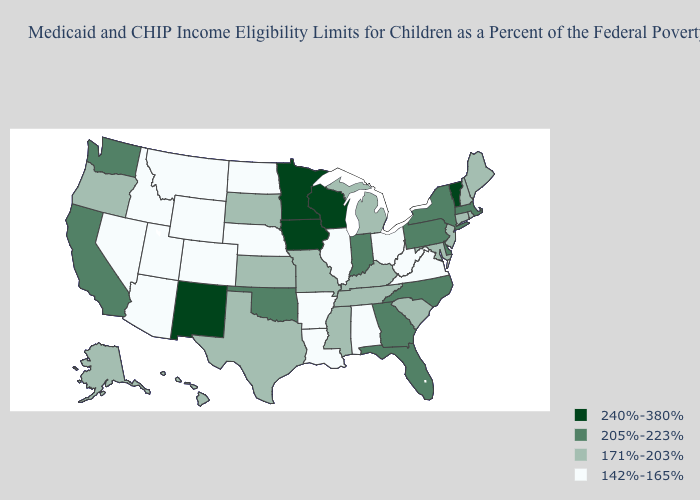Does the map have missing data?
Give a very brief answer. No. What is the highest value in states that border Nebraska?
Concise answer only. 240%-380%. What is the value of Texas?
Be succinct. 171%-203%. Name the states that have a value in the range 205%-223%?
Write a very short answer. California, Delaware, Florida, Georgia, Indiana, Massachusetts, New York, North Carolina, Oklahoma, Pennsylvania, Washington. What is the value of Maine?
Quick response, please. 171%-203%. Among the states that border Idaho , does Oregon have the lowest value?
Short answer required. No. Among the states that border Vermont , does New York have the lowest value?
Quick response, please. No. What is the highest value in states that border New Jersey?
Write a very short answer. 205%-223%. What is the value of Michigan?
Write a very short answer. 171%-203%. Name the states that have a value in the range 240%-380%?
Answer briefly. Iowa, Minnesota, New Mexico, Vermont, Wisconsin. Name the states that have a value in the range 142%-165%?
Write a very short answer. Alabama, Arizona, Arkansas, Colorado, Idaho, Illinois, Louisiana, Montana, Nebraska, Nevada, North Dakota, Ohio, Utah, Virginia, West Virginia, Wyoming. Does Indiana have a lower value than Wyoming?
Keep it brief. No. Name the states that have a value in the range 142%-165%?
Short answer required. Alabama, Arizona, Arkansas, Colorado, Idaho, Illinois, Louisiana, Montana, Nebraska, Nevada, North Dakota, Ohio, Utah, Virginia, West Virginia, Wyoming. What is the value of New York?
Be succinct. 205%-223%. What is the highest value in the USA?
Write a very short answer. 240%-380%. 